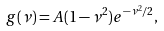<formula> <loc_0><loc_0><loc_500><loc_500>g ( \nu ) = A ( 1 - \nu ^ { 2 } ) e ^ { - \nu ^ { 2 } / 2 } ,</formula> 